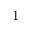<formula> <loc_0><loc_0><loc_500><loc_500>1</formula> 